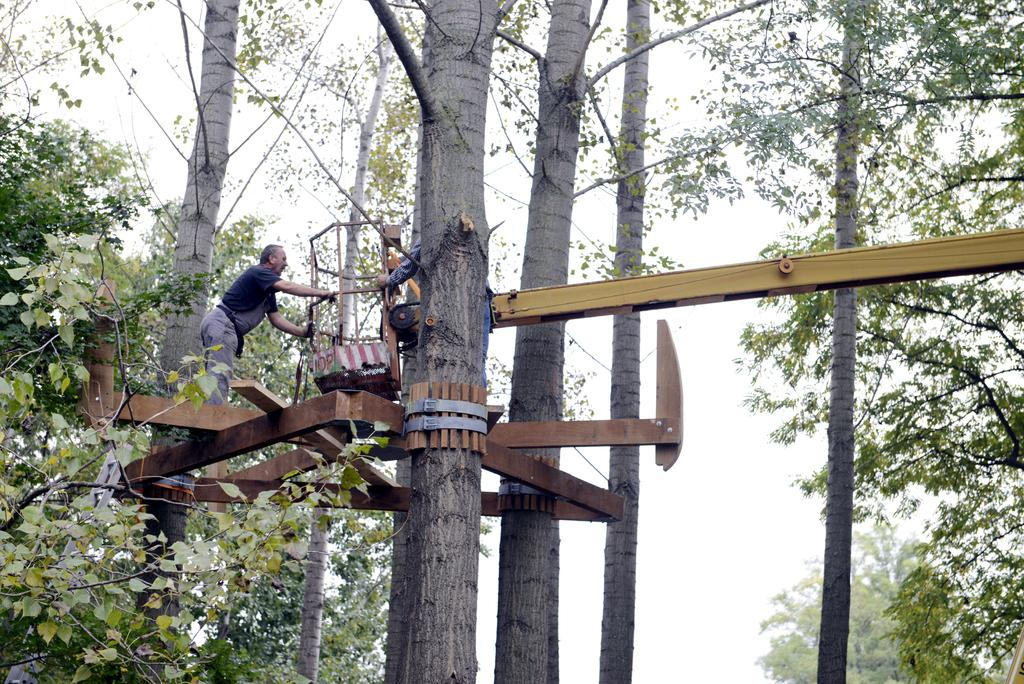Who or what can be seen in the image? There are people in the image. What are the people standing on? The people are standing on iron rods. Are the iron rods connected to anything? Yes, the iron rods are attached to trees. What type of popcorn is being served at the country show in the image? There is no mention of popcorn, a country show, or any event in the image. The image only shows people standing on iron rods attached to trees. 